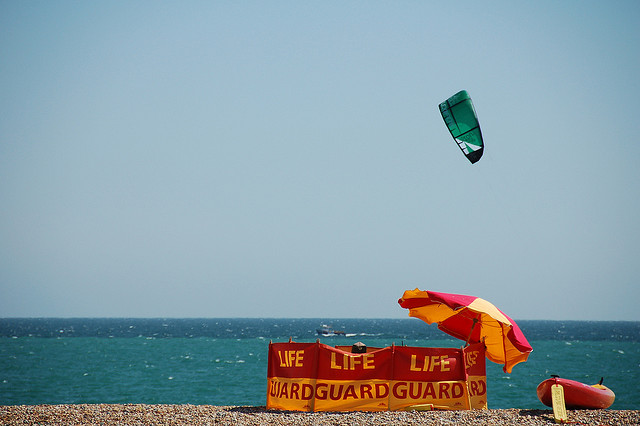<image>Where are the hotels? I don't know where the hotels are. They might be behind the photographer or beside the street. Where are the hotels? It is not clear where the hotels are. They may be behind the photographer or beside the street. 